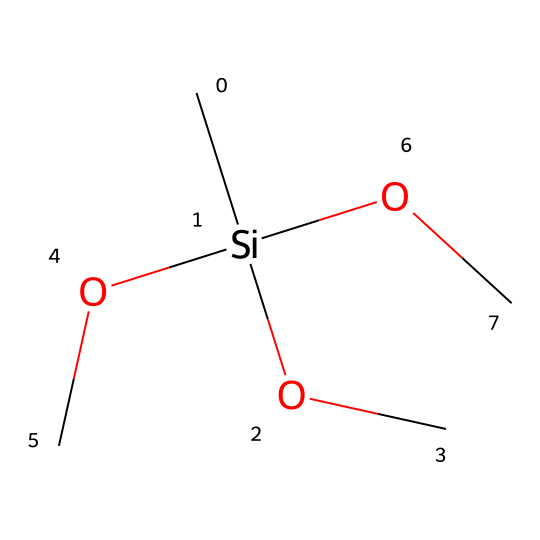how many silicon atoms are present in this silane structure? The provided SMILES shows one silicon atom, as it is represented by "Si" in the structure.
Answer: one what is the total number of oxygen atoms in this molecule? The SMILES indicates three methoxy groups (OC), each containing one oxygen atom. Therefore, there are three oxygen atoms in total.
Answer: three how many carbon atoms are present in the chemical? The chemical has three methoxy groups, each contributing one carbon atom, along with one carbon connected to silicon, totaling four carbon atoms.
Answer: four what type of chemical reaction can silanes like this one participate in due to the presence of functional groups? The presence of methoxy functional groups (OCH3) suggests that this silane can participate in reactions such as hydrolysis, leading to silanol formation.
Answer: hydrolysis what is the likely use of this silane in electronic circuit boards? Silane coupling agents are commonly used to enhance adhesion between organic and inorganic materials on circuit boards, promoting better material compatibility.
Answer: adhesion based on this structure, what kind of bonding is predominantly present between the silicon and the oxygen? The bonding illustrated in the structure is predominantly covalent, as silicon forms strong covalent bonds with the oxygen atoms in the methoxy groups.
Answer: covalent how does the number of methoxy groups influence the properties of the silane coupling agent? The presence of multiple methoxy groups increases the reactivity of the silane and enhances cross-linking capabilities, which improves bonding with substrates.
Answer: reactivity 